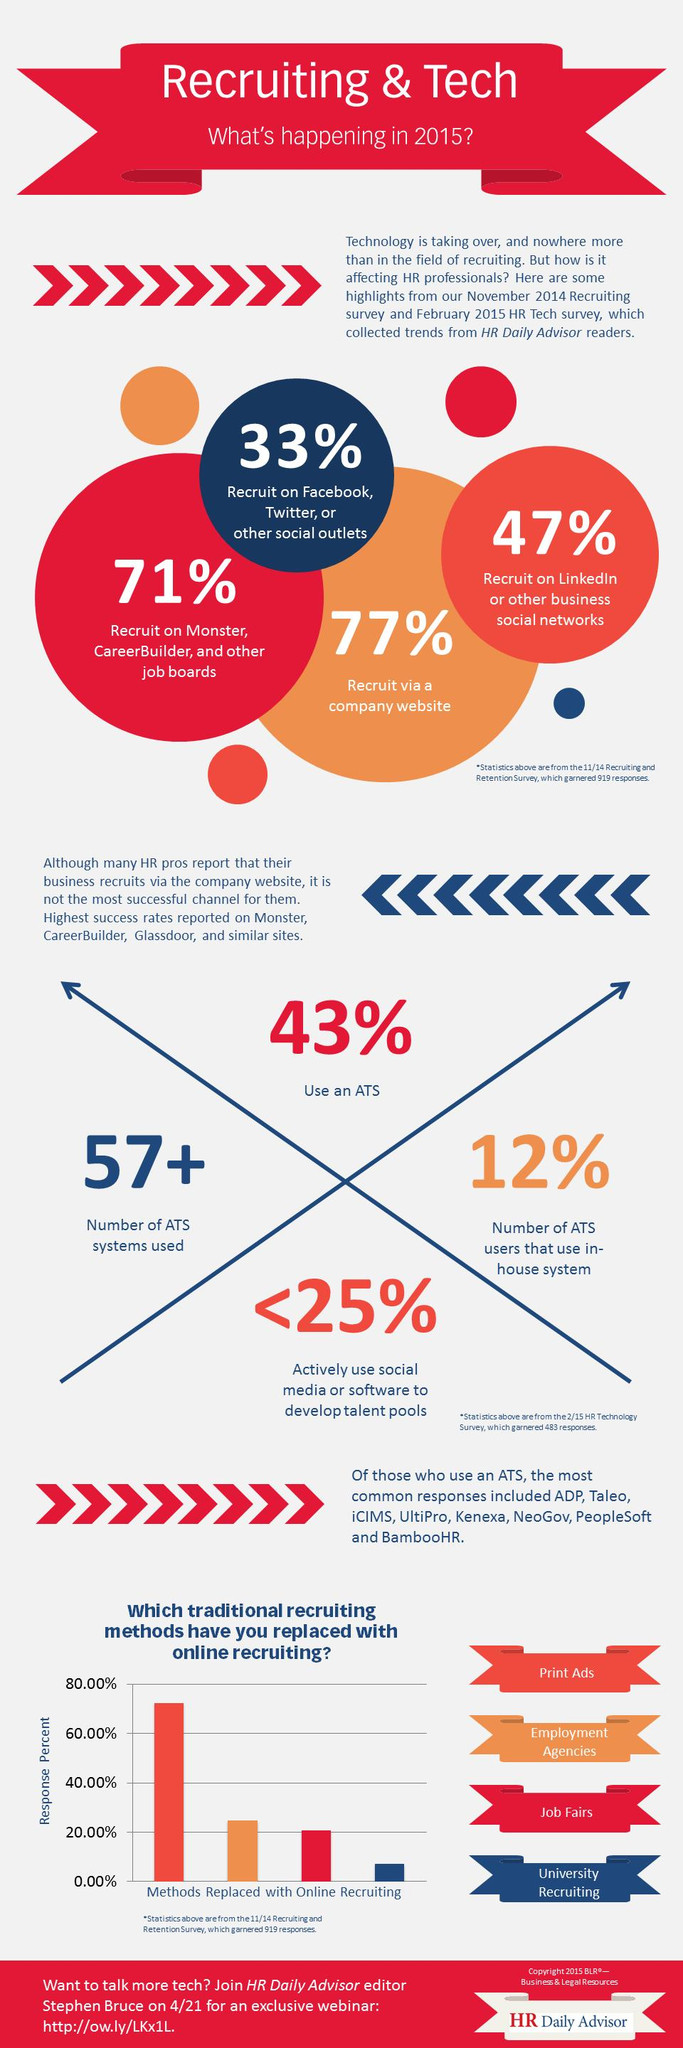Specify some key components in this picture. A recent survey has found that 20.00% of job fair placements have been replaced by online recruiting. Of the employees recruited, 77% were sourced through the Career Builder employment site and other similar platforms. There are three additional ways of employee recruitment other than social media recruitment. The color code assigned to "University Recruiting" is blue. Seventy-one percent of employees are using LinkedIn to recruit, indicating that the platform is an effective tool for job seekers and employers. 